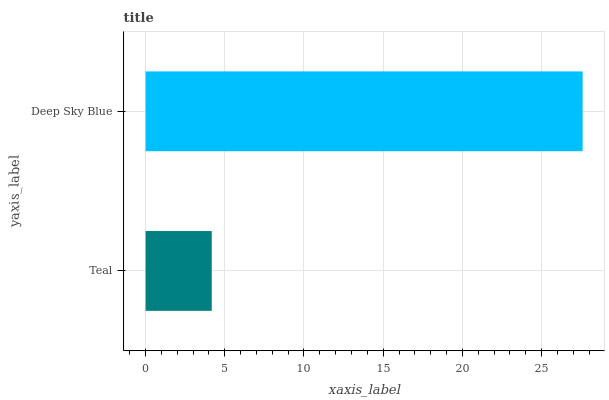Is Teal the minimum?
Answer yes or no. Yes. Is Deep Sky Blue the maximum?
Answer yes or no. Yes. Is Deep Sky Blue the minimum?
Answer yes or no. No. Is Deep Sky Blue greater than Teal?
Answer yes or no. Yes. Is Teal less than Deep Sky Blue?
Answer yes or no. Yes. Is Teal greater than Deep Sky Blue?
Answer yes or no. No. Is Deep Sky Blue less than Teal?
Answer yes or no. No. Is Deep Sky Blue the high median?
Answer yes or no. Yes. Is Teal the low median?
Answer yes or no. Yes. Is Teal the high median?
Answer yes or no. No. Is Deep Sky Blue the low median?
Answer yes or no. No. 